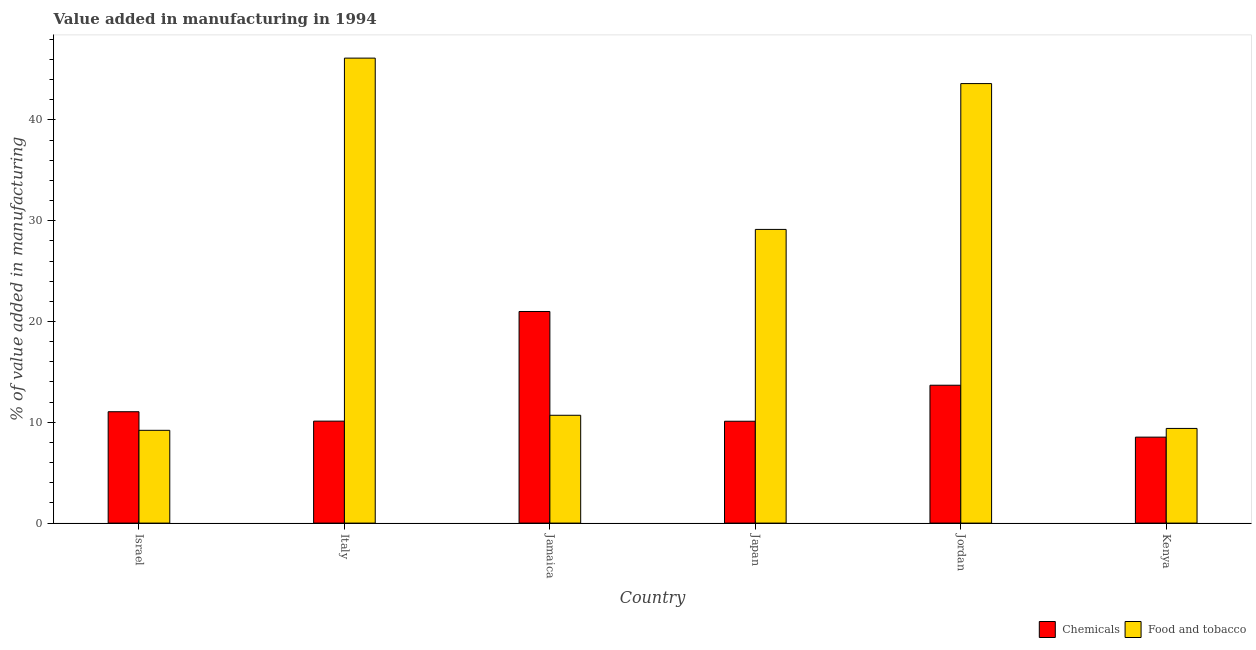How many groups of bars are there?
Provide a short and direct response. 6. Are the number of bars per tick equal to the number of legend labels?
Ensure brevity in your answer.  Yes. How many bars are there on the 4th tick from the left?
Provide a short and direct response. 2. What is the label of the 3rd group of bars from the left?
Provide a short and direct response. Jamaica. In how many cases, is the number of bars for a given country not equal to the number of legend labels?
Your answer should be very brief. 0. What is the value added by  manufacturing chemicals in Israel?
Offer a terse response. 11.05. Across all countries, what is the maximum value added by  manufacturing chemicals?
Provide a short and direct response. 20.99. Across all countries, what is the minimum value added by  manufacturing chemicals?
Your response must be concise. 8.53. In which country was the value added by  manufacturing chemicals maximum?
Offer a very short reply. Jamaica. What is the total value added by  manufacturing chemicals in the graph?
Offer a very short reply. 74.47. What is the difference between the value added by  manufacturing chemicals in Italy and that in Jamaica?
Your answer should be compact. -10.88. What is the difference between the value added by manufacturing food and tobacco in Israel and the value added by  manufacturing chemicals in Japan?
Your answer should be very brief. -0.9. What is the average value added by manufacturing food and tobacco per country?
Offer a very short reply. 24.69. What is the difference between the value added by  manufacturing chemicals and value added by manufacturing food and tobacco in Kenya?
Provide a short and direct response. -0.86. What is the ratio of the value added by  manufacturing chemicals in Israel to that in Japan?
Offer a very short reply. 1.09. Is the value added by manufacturing food and tobacco in Israel less than that in Italy?
Give a very brief answer. Yes. Is the difference between the value added by  manufacturing chemicals in Jamaica and Jordan greater than the difference between the value added by manufacturing food and tobacco in Jamaica and Jordan?
Keep it short and to the point. Yes. What is the difference between the highest and the second highest value added by manufacturing food and tobacco?
Your answer should be very brief. 2.53. What is the difference between the highest and the lowest value added by  manufacturing chemicals?
Your response must be concise. 12.47. Is the sum of the value added by  manufacturing chemicals in Israel and Japan greater than the maximum value added by manufacturing food and tobacco across all countries?
Offer a very short reply. No. What does the 1st bar from the left in Jordan represents?
Keep it short and to the point. Chemicals. What does the 1st bar from the right in Japan represents?
Ensure brevity in your answer.  Food and tobacco. How many bars are there?
Offer a terse response. 12. How many countries are there in the graph?
Make the answer very short. 6. Does the graph contain grids?
Make the answer very short. No. How are the legend labels stacked?
Keep it short and to the point. Horizontal. What is the title of the graph?
Ensure brevity in your answer.  Value added in manufacturing in 1994. What is the label or title of the Y-axis?
Make the answer very short. % of value added in manufacturing. What is the % of value added in manufacturing of Chemicals in Israel?
Give a very brief answer. 11.05. What is the % of value added in manufacturing in Food and tobacco in Israel?
Your answer should be compact. 9.21. What is the % of value added in manufacturing of Chemicals in Italy?
Keep it short and to the point. 10.12. What is the % of value added in manufacturing in Food and tobacco in Italy?
Offer a terse response. 46.13. What is the % of value added in manufacturing in Chemicals in Jamaica?
Offer a terse response. 20.99. What is the % of value added in manufacturing of Food and tobacco in Jamaica?
Provide a short and direct response. 10.7. What is the % of value added in manufacturing of Chemicals in Japan?
Offer a terse response. 10.1. What is the % of value added in manufacturing of Food and tobacco in Japan?
Your response must be concise. 29.14. What is the % of value added in manufacturing in Chemicals in Jordan?
Your answer should be compact. 13.68. What is the % of value added in manufacturing of Food and tobacco in Jordan?
Keep it short and to the point. 43.6. What is the % of value added in manufacturing in Chemicals in Kenya?
Your response must be concise. 8.53. What is the % of value added in manufacturing in Food and tobacco in Kenya?
Keep it short and to the point. 9.39. Across all countries, what is the maximum % of value added in manufacturing of Chemicals?
Offer a very short reply. 20.99. Across all countries, what is the maximum % of value added in manufacturing in Food and tobacco?
Give a very brief answer. 46.13. Across all countries, what is the minimum % of value added in manufacturing of Chemicals?
Your answer should be very brief. 8.53. Across all countries, what is the minimum % of value added in manufacturing of Food and tobacco?
Provide a succinct answer. 9.21. What is the total % of value added in manufacturing in Chemicals in the graph?
Provide a succinct answer. 74.47. What is the total % of value added in manufacturing in Food and tobacco in the graph?
Provide a succinct answer. 148.17. What is the difference between the % of value added in manufacturing in Chemicals in Israel and that in Italy?
Your answer should be very brief. 0.93. What is the difference between the % of value added in manufacturing in Food and tobacco in Israel and that in Italy?
Offer a very short reply. -36.92. What is the difference between the % of value added in manufacturing in Chemicals in Israel and that in Jamaica?
Offer a terse response. -9.94. What is the difference between the % of value added in manufacturing of Food and tobacco in Israel and that in Jamaica?
Your response must be concise. -1.49. What is the difference between the % of value added in manufacturing of Chemicals in Israel and that in Japan?
Your response must be concise. 0.94. What is the difference between the % of value added in manufacturing of Food and tobacco in Israel and that in Japan?
Offer a terse response. -19.93. What is the difference between the % of value added in manufacturing of Chemicals in Israel and that in Jordan?
Provide a short and direct response. -2.63. What is the difference between the % of value added in manufacturing in Food and tobacco in Israel and that in Jordan?
Make the answer very short. -34.4. What is the difference between the % of value added in manufacturing in Chemicals in Israel and that in Kenya?
Provide a short and direct response. 2.52. What is the difference between the % of value added in manufacturing of Food and tobacco in Israel and that in Kenya?
Your answer should be compact. -0.19. What is the difference between the % of value added in manufacturing of Chemicals in Italy and that in Jamaica?
Your answer should be compact. -10.88. What is the difference between the % of value added in manufacturing of Food and tobacco in Italy and that in Jamaica?
Offer a very short reply. 35.43. What is the difference between the % of value added in manufacturing of Chemicals in Italy and that in Japan?
Keep it short and to the point. 0.01. What is the difference between the % of value added in manufacturing of Food and tobacco in Italy and that in Japan?
Offer a very short reply. 16.99. What is the difference between the % of value added in manufacturing in Chemicals in Italy and that in Jordan?
Provide a short and direct response. -3.56. What is the difference between the % of value added in manufacturing in Food and tobacco in Italy and that in Jordan?
Your answer should be very brief. 2.53. What is the difference between the % of value added in manufacturing of Chemicals in Italy and that in Kenya?
Ensure brevity in your answer.  1.59. What is the difference between the % of value added in manufacturing of Food and tobacco in Italy and that in Kenya?
Your answer should be very brief. 36.74. What is the difference between the % of value added in manufacturing of Chemicals in Jamaica and that in Japan?
Your answer should be compact. 10.89. What is the difference between the % of value added in manufacturing in Food and tobacco in Jamaica and that in Japan?
Provide a short and direct response. -18.44. What is the difference between the % of value added in manufacturing in Chemicals in Jamaica and that in Jordan?
Your answer should be very brief. 7.32. What is the difference between the % of value added in manufacturing in Food and tobacco in Jamaica and that in Jordan?
Your answer should be compact. -32.91. What is the difference between the % of value added in manufacturing of Chemicals in Jamaica and that in Kenya?
Keep it short and to the point. 12.47. What is the difference between the % of value added in manufacturing of Food and tobacco in Jamaica and that in Kenya?
Ensure brevity in your answer.  1.3. What is the difference between the % of value added in manufacturing in Chemicals in Japan and that in Jordan?
Offer a terse response. -3.57. What is the difference between the % of value added in manufacturing of Food and tobacco in Japan and that in Jordan?
Provide a succinct answer. -14.47. What is the difference between the % of value added in manufacturing of Chemicals in Japan and that in Kenya?
Provide a succinct answer. 1.58. What is the difference between the % of value added in manufacturing in Food and tobacco in Japan and that in Kenya?
Your answer should be compact. 19.74. What is the difference between the % of value added in manufacturing in Chemicals in Jordan and that in Kenya?
Ensure brevity in your answer.  5.15. What is the difference between the % of value added in manufacturing in Food and tobacco in Jordan and that in Kenya?
Make the answer very short. 34.21. What is the difference between the % of value added in manufacturing of Chemicals in Israel and the % of value added in manufacturing of Food and tobacco in Italy?
Offer a very short reply. -35.08. What is the difference between the % of value added in manufacturing of Chemicals in Israel and the % of value added in manufacturing of Food and tobacco in Jamaica?
Ensure brevity in your answer.  0.35. What is the difference between the % of value added in manufacturing in Chemicals in Israel and the % of value added in manufacturing in Food and tobacco in Japan?
Your answer should be very brief. -18.09. What is the difference between the % of value added in manufacturing in Chemicals in Israel and the % of value added in manufacturing in Food and tobacco in Jordan?
Keep it short and to the point. -32.55. What is the difference between the % of value added in manufacturing in Chemicals in Israel and the % of value added in manufacturing in Food and tobacco in Kenya?
Your answer should be compact. 1.66. What is the difference between the % of value added in manufacturing in Chemicals in Italy and the % of value added in manufacturing in Food and tobacco in Jamaica?
Make the answer very short. -0.58. What is the difference between the % of value added in manufacturing in Chemicals in Italy and the % of value added in manufacturing in Food and tobacco in Japan?
Offer a terse response. -19.02. What is the difference between the % of value added in manufacturing of Chemicals in Italy and the % of value added in manufacturing of Food and tobacco in Jordan?
Keep it short and to the point. -33.49. What is the difference between the % of value added in manufacturing in Chemicals in Italy and the % of value added in manufacturing in Food and tobacco in Kenya?
Keep it short and to the point. 0.72. What is the difference between the % of value added in manufacturing in Chemicals in Jamaica and the % of value added in manufacturing in Food and tobacco in Japan?
Your answer should be very brief. -8.14. What is the difference between the % of value added in manufacturing in Chemicals in Jamaica and the % of value added in manufacturing in Food and tobacco in Jordan?
Provide a short and direct response. -22.61. What is the difference between the % of value added in manufacturing of Chemicals in Jamaica and the % of value added in manufacturing of Food and tobacco in Kenya?
Your response must be concise. 11.6. What is the difference between the % of value added in manufacturing in Chemicals in Japan and the % of value added in manufacturing in Food and tobacco in Jordan?
Make the answer very short. -33.5. What is the difference between the % of value added in manufacturing of Chemicals in Japan and the % of value added in manufacturing of Food and tobacco in Kenya?
Offer a very short reply. 0.71. What is the difference between the % of value added in manufacturing in Chemicals in Jordan and the % of value added in manufacturing in Food and tobacco in Kenya?
Your response must be concise. 4.28. What is the average % of value added in manufacturing in Chemicals per country?
Your answer should be very brief. 12.41. What is the average % of value added in manufacturing in Food and tobacco per country?
Your response must be concise. 24.69. What is the difference between the % of value added in manufacturing in Chemicals and % of value added in manufacturing in Food and tobacco in Israel?
Give a very brief answer. 1.84. What is the difference between the % of value added in manufacturing of Chemicals and % of value added in manufacturing of Food and tobacco in Italy?
Make the answer very short. -36.01. What is the difference between the % of value added in manufacturing in Chemicals and % of value added in manufacturing in Food and tobacco in Jamaica?
Offer a terse response. 10.3. What is the difference between the % of value added in manufacturing in Chemicals and % of value added in manufacturing in Food and tobacco in Japan?
Give a very brief answer. -19.03. What is the difference between the % of value added in manufacturing of Chemicals and % of value added in manufacturing of Food and tobacco in Jordan?
Your response must be concise. -29.93. What is the difference between the % of value added in manufacturing in Chemicals and % of value added in manufacturing in Food and tobacco in Kenya?
Ensure brevity in your answer.  -0.86. What is the ratio of the % of value added in manufacturing in Chemicals in Israel to that in Italy?
Keep it short and to the point. 1.09. What is the ratio of the % of value added in manufacturing of Food and tobacco in Israel to that in Italy?
Make the answer very short. 0.2. What is the ratio of the % of value added in manufacturing of Chemicals in Israel to that in Jamaica?
Ensure brevity in your answer.  0.53. What is the ratio of the % of value added in manufacturing of Food and tobacco in Israel to that in Jamaica?
Provide a short and direct response. 0.86. What is the ratio of the % of value added in manufacturing in Chemicals in Israel to that in Japan?
Offer a very short reply. 1.09. What is the ratio of the % of value added in manufacturing in Food and tobacco in Israel to that in Japan?
Keep it short and to the point. 0.32. What is the ratio of the % of value added in manufacturing of Chemicals in Israel to that in Jordan?
Provide a succinct answer. 0.81. What is the ratio of the % of value added in manufacturing of Food and tobacco in Israel to that in Jordan?
Provide a short and direct response. 0.21. What is the ratio of the % of value added in manufacturing in Chemicals in Israel to that in Kenya?
Give a very brief answer. 1.3. What is the ratio of the % of value added in manufacturing of Chemicals in Italy to that in Jamaica?
Your response must be concise. 0.48. What is the ratio of the % of value added in manufacturing in Food and tobacco in Italy to that in Jamaica?
Offer a very short reply. 4.31. What is the ratio of the % of value added in manufacturing of Chemicals in Italy to that in Japan?
Your answer should be very brief. 1. What is the ratio of the % of value added in manufacturing of Food and tobacco in Italy to that in Japan?
Offer a very short reply. 1.58. What is the ratio of the % of value added in manufacturing of Chemicals in Italy to that in Jordan?
Give a very brief answer. 0.74. What is the ratio of the % of value added in manufacturing of Food and tobacco in Italy to that in Jordan?
Provide a short and direct response. 1.06. What is the ratio of the % of value added in manufacturing in Chemicals in Italy to that in Kenya?
Make the answer very short. 1.19. What is the ratio of the % of value added in manufacturing in Food and tobacco in Italy to that in Kenya?
Provide a succinct answer. 4.91. What is the ratio of the % of value added in manufacturing of Chemicals in Jamaica to that in Japan?
Offer a terse response. 2.08. What is the ratio of the % of value added in manufacturing in Food and tobacco in Jamaica to that in Japan?
Ensure brevity in your answer.  0.37. What is the ratio of the % of value added in manufacturing of Chemicals in Jamaica to that in Jordan?
Keep it short and to the point. 1.53. What is the ratio of the % of value added in manufacturing of Food and tobacco in Jamaica to that in Jordan?
Your answer should be very brief. 0.25. What is the ratio of the % of value added in manufacturing of Chemicals in Jamaica to that in Kenya?
Offer a terse response. 2.46. What is the ratio of the % of value added in manufacturing of Food and tobacco in Jamaica to that in Kenya?
Your answer should be compact. 1.14. What is the ratio of the % of value added in manufacturing of Chemicals in Japan to that in Jordan?
Provide a short and direct response. 0.74. What is the ratio of the % of value added in manufacturing of Food and tobacco in Japan to that in Jordan?
Offer a terse response. 0.67. What is the ratio of the % of value added in manufacturing in Chemicals in Japan to that in Kenya?
Provide a short and direct response. 1.18. What is the ratio of the % of value added in manufacturing of Food and tobacco in Japan to that in Kenya?
Provide a succinct answer. 3.1. What is the ratio of the % of value added in manufacturing in Chemicals in Jordan to that in Kenya?
Offer a terse response. 1.6. What is the ratio of the % of value added in manufacturing in Food and tobacco in Jordan to that in Kenya?
Your response must be concise. 4.64. What is the difference between the highest and the second highest % of value added in manufacturing in Chemicals?
Your response must be concise. 7.32. What is the difference between the highest and the second highest % of value added in manufacturing of Food and tobacco?
Provide a short and direct response. 2.53. What is the difference between the highest and the lowest % of value added in manufacturing of Chemicals?
Provide a short and direct response. 12.47. What is the difference between the highest and the lowest % of value added in manufacturing of Food and tobacco?
Your response must be concise. 36.92. 